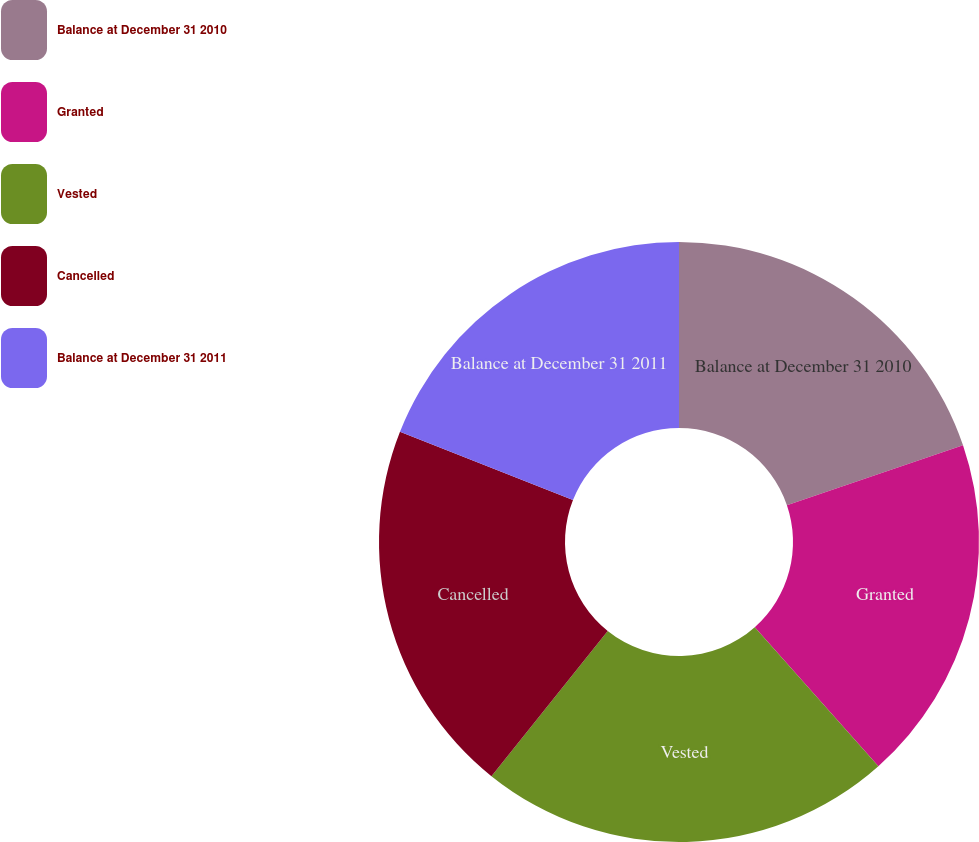<chart> <loc_0><loc_0><loc_500><loc_500><pie_chart><fcel>Balance at December 31 2010<fcel>Granted<fcel>Vested<fcel>Cancelled<fcel>Balance at December 31 2011<nl><fcel>19.78%<fcel>18.65%<fcel>22.32%<fcel>20.24%<fcel>19.01%<nl></chart> 